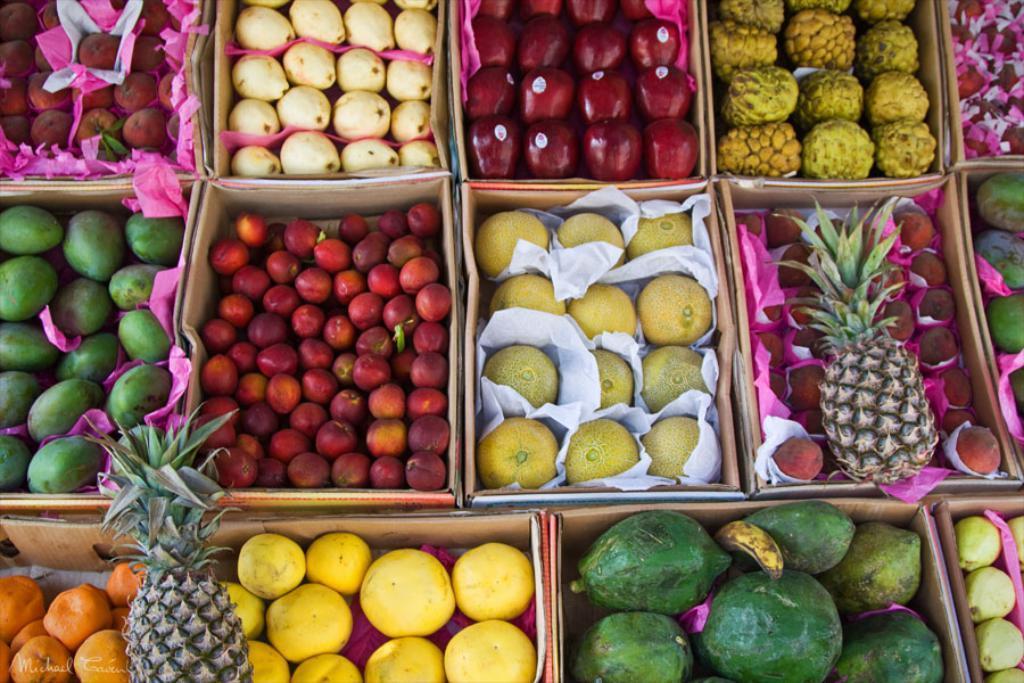In one or two sentences, can you explain what this image depicts? In this image there are fruits in the boxes, there are stickers on the fruits, there are papers, there is text towards the bottom of the image. 